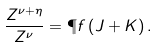<formula> <loc_0><loc_0><loc_500><loc_500>\frac { Z ^ { \nu + \eta } } { Z ^ { \nu } } = \P f \left ( J + K \right ) .</formula> 